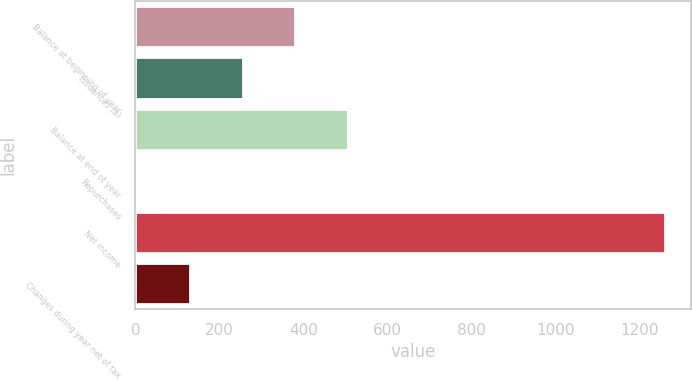Convert chart. <chart><loc_0><loc_0><loc_500><loc_500><bar_chart><fcel>Balance at beginning of year<fcel>Issuances (a)<fcel>Balance at end of year<fcel>Repurchases<fcel>Net income<fcel>Changes during year net of tax<nl><fcel>381.1<fcel>255.4<fcel>506.8<fcel>4<fcel>1261<fcel>129.7<nl></chart> 